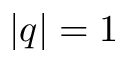Convert formula to latex. <formula><loc_0><loc_0><loc_500><loc_500>| q | = 1</formula> 